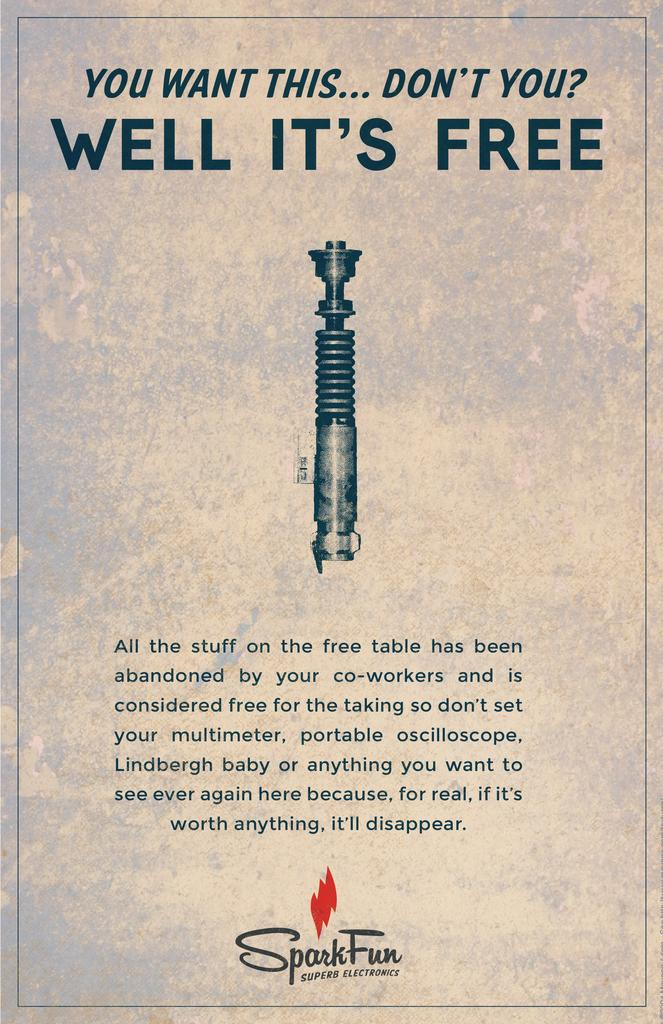<image>
Create a compact narrative representing the image presented. An advertisement for all the stuff on the free table abandoned by co-workers. 